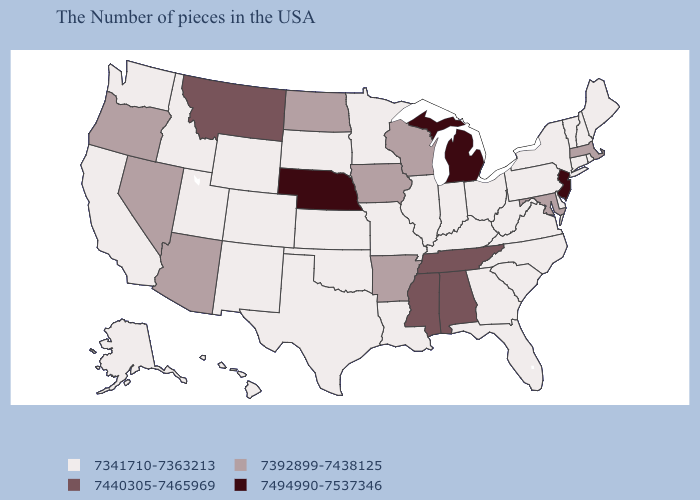What is the value of Kansas?
Short answer required. 7341710-7363213. Does Alabama have a lower value than Wyoming?
Keep it brief. No. What is the value of Iowa?
Answer briefly. 7392899-7438125. Which states have the lowest value in the USA?
Keep it brief. Maine, Rhode Island, New Hampshire, Vermont, Connecticut, New York, Delaware, Pennsylvania, Virginia, North Carolina, South Carolina, West Virginia, Ohio, Florida, Georgia, Kentucky, Indiana, Illinois, Louisiana, Missouri, Minnesota, Kansas, Oklahoma, Texas, South Dakota, Wyoming, Colorado, New Mexico, Utah, Idaho, California, Washington, Alaska, Hawaii. Name the states that have a value in the range 7440305-7465969?
Write a very short answer. Alabama, Tennessee, Mississippi, Montana. What is the value of Hawaii?
Answer briefly. 7341710-7363213. What is the lowest value in the Northeast?
Concise answer only. 7341710-7363213. Does New Jersey have the lowest value in the USA?
Give a very brief answer. No. Name the states that have a value in the range 7494990-7537346?
Answer briefly. New Jersey, Michigan, Nebraska. Among the states that border Idaho , which have the highest value?
Be succinct. Montana. Which states hav the highest value in the MidWest?
Write a very short answer. Michigan, Nebraska. What is the highest value in states that border Kansas?
Be succinct. 7494990-7537346. Name the states that have a value in the range 7440305-7465969?
Concise answer only. Alabama, Tennessee, Mississippi, Montana. Does Connecticut have the highest value in the Northeast?
Write a very short answer. No. 